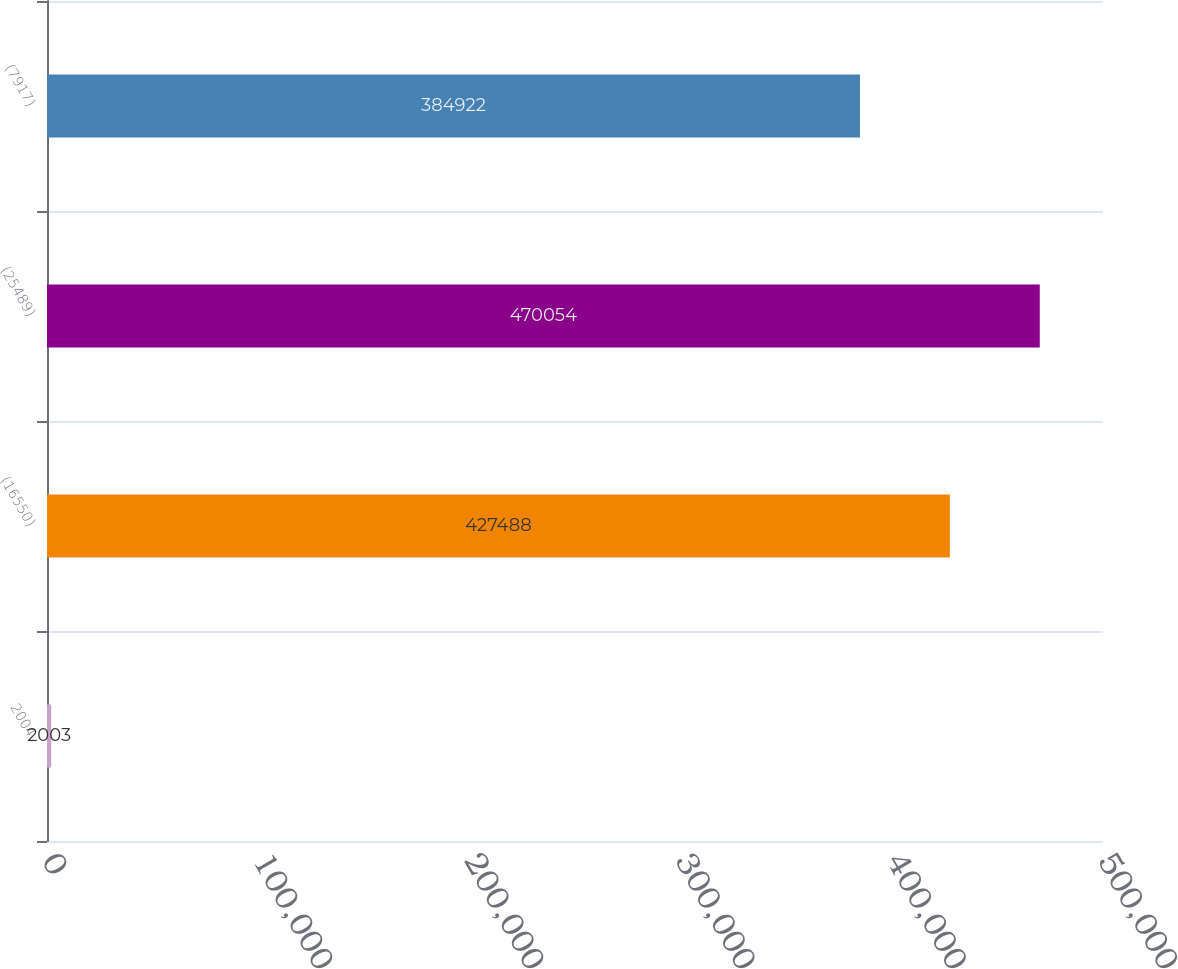Convert chart. <chart><loc_0><loc_0><loc_500><loc_500><bar_chart><fcel>2004<fcel>(16550)<fcel>(25489)<fcel>(7917)<nl><fcel>2003<fcel>427488<fcel>470054<fcel>384922<nl></chart> 